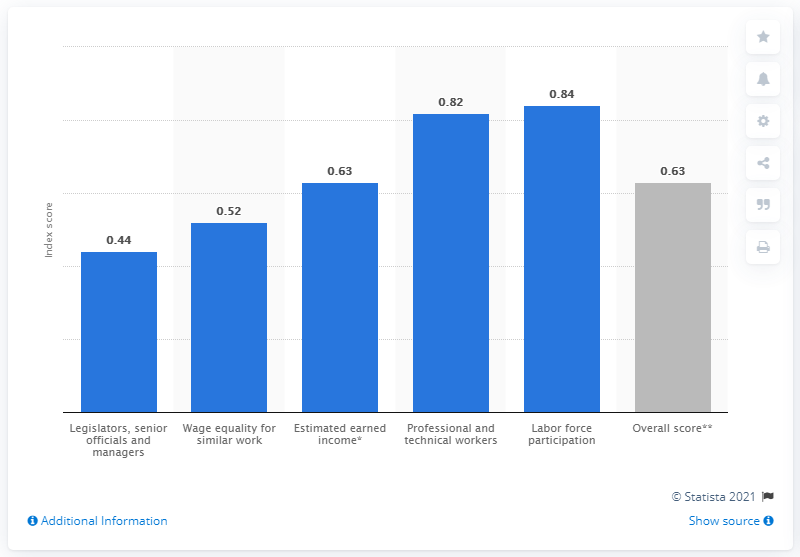What does the score of 0.44 under 'Legislators, senior officials and managers' indicate about gender equality in these high-level positions in Peru? The score of 0.44 in 'Legislators, senior officials, and managers' suggests gender inequality in these high-level positions in Peru. A lower score implies a larger gap between the participation and opportunities available to men compared to women. 